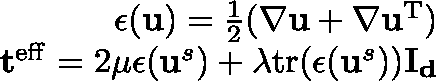Convert formula to latex. <formula><loc_0><loc_0><loc_500><loc_500>\begin{array} { r } { \epsilon ( u ) = \frac { 1 } { 2 } ( \nabla u + \nabla u ^ { T } ) } \\ { t ^ { e f f } = 2 \mu \epsilon ( u ^ { s } ) + \lambda t r ( \epsilon ( u ^ { s } ) ) I _ { d } } \end{array}</formula> 